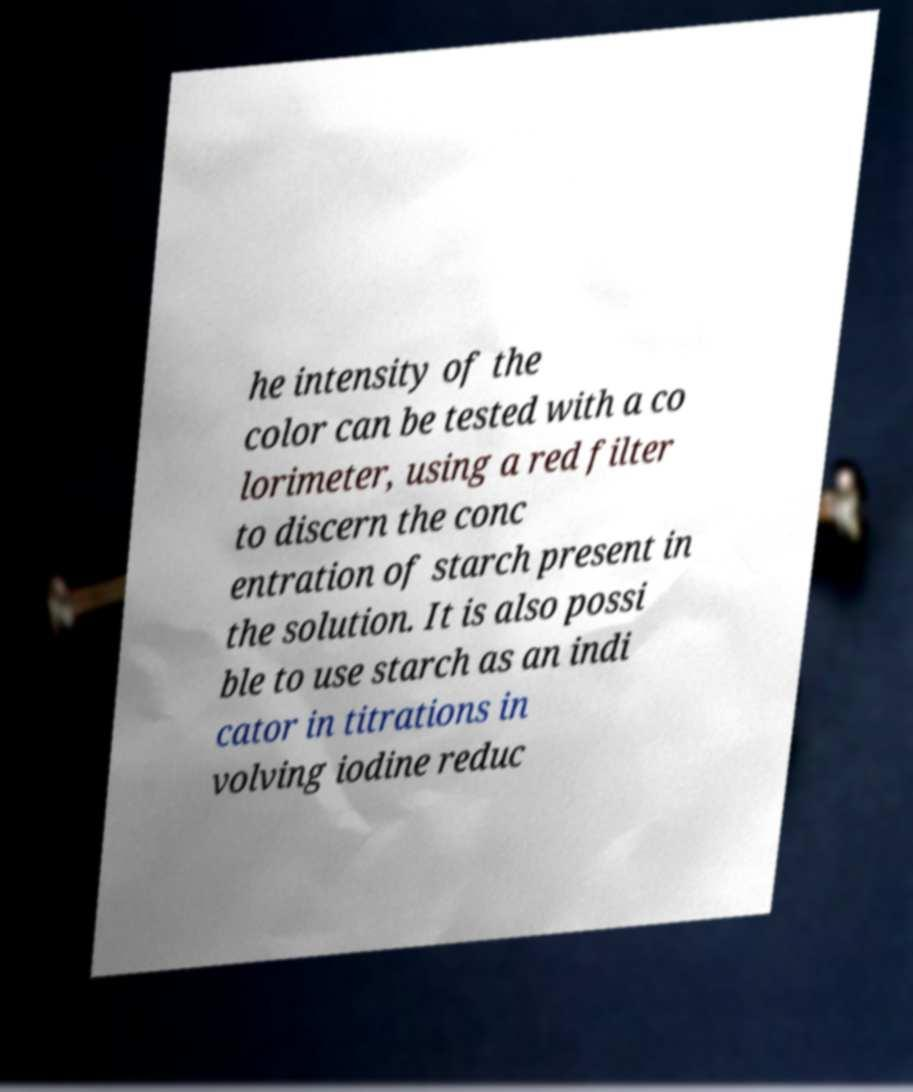Could you assist in decoding the text presented in this image and type it out clearly? he intensity of the color can be tested with a co lorimeter, using a red filter to discern the conc entration of starch present in the solution. It is also possi ble to use starch as an indi cator in titrations in volving iodine reduc 